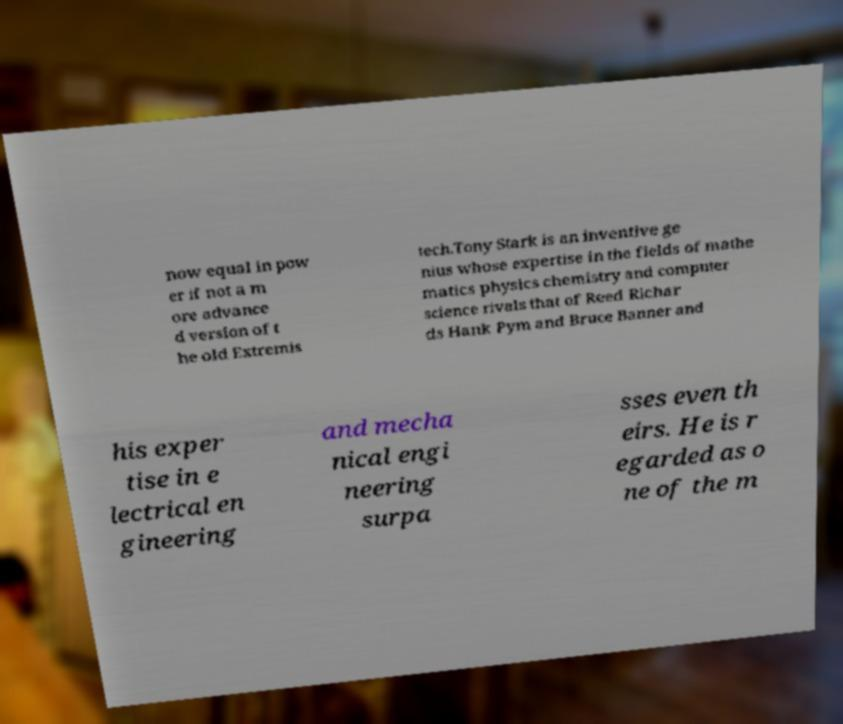Please read and relay the text visible in this image. What does it say? now equal in pow er if not a m ore advance d version of t he old Extremis tech.Tony Stark is an inventive ge nius whose expertise in the fields of mathe matics physics chemistry and computer science rivals that of Reed Richar ds Hank Pym and Bruce Banner and his exper tise in e lectrical en gineering and mecha nical engi neering surpa sses even th eirs. He is r egarded as o ne of the m 